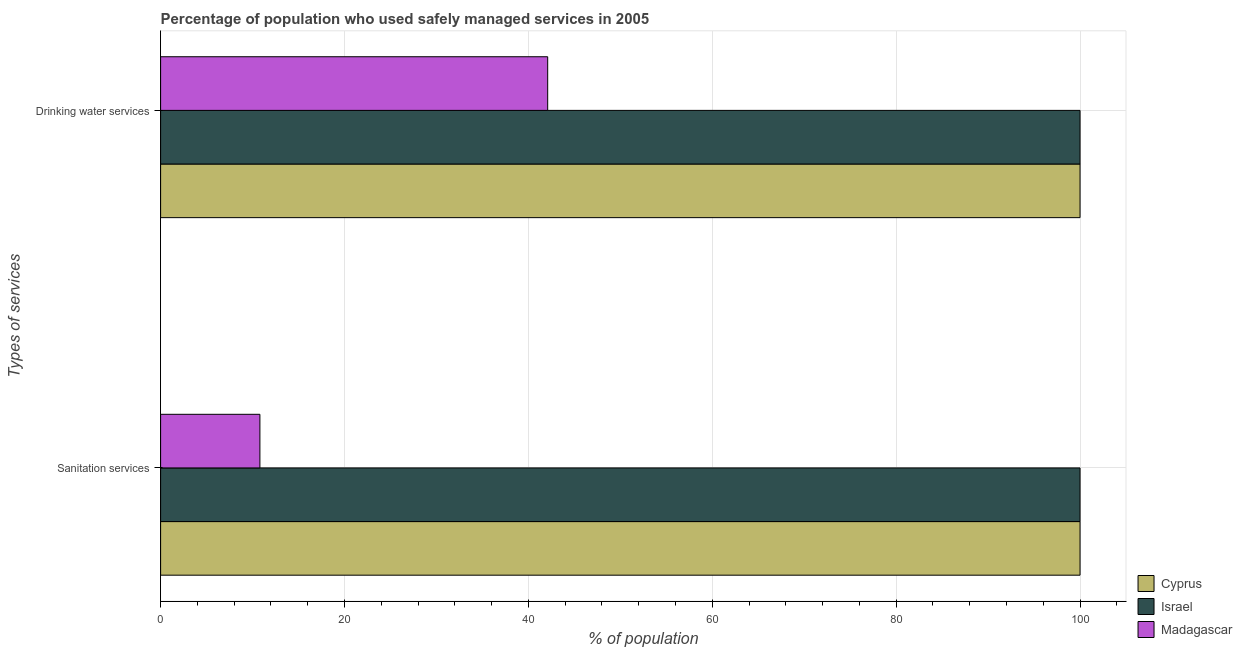What is the label of the 2nd group of bars from the top?
Provide a short and direct response. Sanitation services. In which country was the percentage of population who used drinking water services maximum?
Make the answer very short. Cyprus. In which country was the percentage of population who used sanitation services minimum?
Make the answer very short. Madagascar. What is the total percentage of population who used sanitation services in the graph?
Ensure brevity in your answer.  210.8. What is the difference between the percentage of population who used drinking water services in Madagascar and that in Israel?
Your answer should be very brief. -57.9. What is the difference between the percentage of population who used drinking water services in Cyprus and the percentage of population who used sanitation services in Madagascar?
Your response must be concise. 89.2. What is the average percentage of population who used sanitation services per country?
Give a very brief answer. 70.27. In how many countries, is the percentage of population who used sanitation services greater than 80 %?
Provide a succinct answer. 2. What is the ratio of the percentage of population who used sanitation services in Israel to that in Cyprus?
Your answer should be very brief. 1. Is the percentage of population who used sanitation services in Israel less than that in Cyprus?
Offer a very short reply. No. In how many countries, is the percentage of population who used drinking water services greater than the average percentage of population who used drinking water services taken over all countries?
Provide a short and direct response. 2. What does the 1st bar from the top in Sanitation services represents?
Your answer should be very brief. Madagascar. What does the 3rd bar from the bottom in Sanitation services represents?
Offer a very short reply. Madagascar. Are all the bars in the graph horizontal?
Provide a succinct answer. Yes. How many countries are there in the graph?
Provide a short and direct response. 3. Are the values on the major ticks of X-axis written in scientific E-notation?
Your answer should be very brief. No. Where does the legend appear in the graph?
Offer a very short reply. Bottom right. How many legend labels are there?
Your answer should be compact. 3. How are the legend labels stacked?
Your answer should be compact. Vertical. What is the title of the graph?
Your answer should be very brief. Percentage of population who used safely managed services in 2005. What is the label or title of the X-axis?
Provide a succinct answer. % of population. What is the label or title of the Y-axis?
Provide a short and direct response. Types of services. What is the % of population of Cyprus in Sanitation services?
Give a very brief answer. 100. What is the % of population in Madagascar in Drinking water services?
Provide a succinct answer. 42.1. Across all Types of services, what is the maximum % of population in Cyprus?
Provide a succinct answer. 100. Across all Types of services, what is the maximum % of population of Madagascar?
Make the answer very short. 42.1. Across all Types of services, what is the minimum % of population of Cyprus?
Offer a very short reply. 100. What is the total % of population of Israel in the graph?
Your answer should be very brief. 200. What is the total % of population of Madagascar in the graph?
Provide a succinct answer. 52.9. What is the difference between the % of population of Cyprus in Sanitation services and that in Drinking water services?
Make the answer very short. 0. What is the difference between the % of population of Madagascar in Sanitation services and that in Drinking water services?
Keep it short and to the point. -31.3. What is the difference between the % of population of Cyprus in Sanitation services and the % of population of Israel in Drinking water services?
Ensure brevity in your answer.  0. What is the difference between the % of population in Cyprus in Sanitation services and the % of population in Madagascar in Drinking water services?
Keep it short and to the point. 57.9. What is the difference between the % of population in Israel in Sanitation services and the % of population in Madagascar in Drinking water services?
Make the answer very short. 57.9. What is the average % of population in Israel per Types of services?
Keep it short and to the point. 100. What is the average % of population in Madagascar per Types of services?
Provide a short and direct response. 26.45. What is the difference between the % of population of Cyprus and % of population of Israel in Sanitation services?
Provide a succinct answer. 0. What is the difference between the % of population of Cyprus and % of population of Madagascar in Sanitation services?
Ensure brevity in your answer.  89.2. What is the difference between the % of population in Israel and % of population in Madagascar in Sanitation services?
Provide a short and direct response. 89.2. What is the difference between the % of population of Cyprus and % of population of Madagascar in Drinking water services?
Keep it short and to the point. 57.9. What is the difference between the % of population of Israel and % of population of Madagascar in Drinking water services?
Keep it short and to the point. 57.9. What is the ratio of the % of population of Cyprus in Sanitation services to that in Drinking water services?
Give a very brief answer. 1. What is the ratio of the % of population in Israel in Sanitation services to that in Drinking water services?
Offer a very short reply. 1. What is the ratio of the % of population of Madagascar in Sanitation services to that in Drinking water services?
Keep it short and to the point. 0.26. What is the difference between the highest and the second highest % of population in Madagascar?
Keep it short and to the point. 31.3. What is the difference between the highest and the lowest % of population in Madagascar?
Your response must be concise. 31.3. 